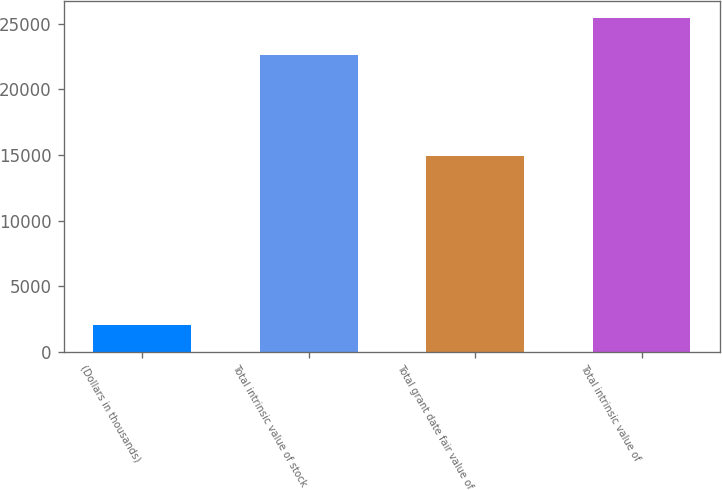Convert chart to OTSL. <chart><loc_0><loc_0><loc_500><loc_500><bar_chart><fcel>(Dollars in thousands)<fcel>Total intrinsic value of stock<fcel>Total grant date fair value of<fcel>Total intrinsic value of<nl><fcel>2014<fcel>22634.9<fcel>14935<fcel>25453<nl></chart> 